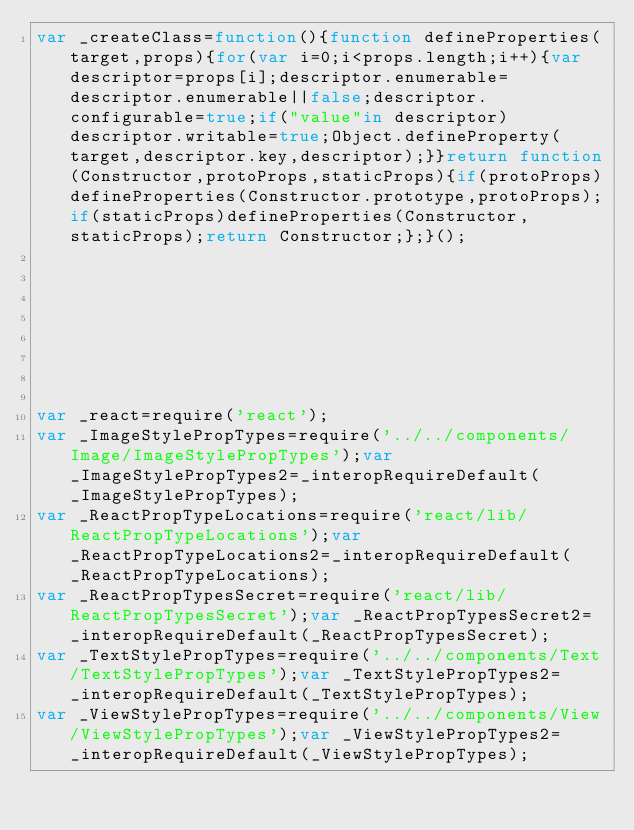Convert code to text. <code><loc_0><loc_0><loc_500><loc_500><_JavaScript_>var _createClass=function(){function defineProperties(target,props){for(var i=0;i<props.length;i++){var descriptor=props[i];descriptor.enumerable=descriptor.enumerable||false;descriptor.configurable=true;if("value"in descriptor)descriptor.writable=true;Object.defineProperty(target,descriptor.key,descriptor);}}return function(Constructor,protoProps,staticProps){if(protoProps)defineProperties(Constructor.prototype,protoProps);if(staticProps)defineProperties(Constructor,staticProps);return Constructor;};}();








var _react=require('react');
var _ImageStylePropTypes=require('../../components/Image/ImageStylePropTypes');var _ImageStylePropTypes2=_interopRequireDefault(_ImageStylePropTypes);
var _ReactPropTypeLocations=require('react/lib/ReactPropTypeLocations');var _ReactPropTypeLocations2=_interopRequireDefault(_ReactPropTypeLocations);
var _ReactPropTypesSecret=require('react/lib/ReactPropTypesSecret');var _ReactPropTypesSecret2=_interopRequireDefault(_ReactPropTypesSecret);
var _TextStylePropTypes=require('../../components/Text/TextStylePropTypes');var _TextStylePropTypes2=_interopRequireDefault(_TextStylePropTypes);
var _ViewStylePropTypes=require('../../components/View/ViewStylePropTypes');var _ViewStylePropTypes2=_interopRequireDefault(_ViewStylePropTypes);</code> 